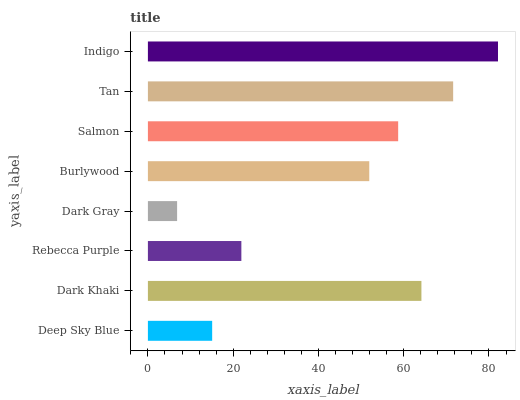Is Dark Gray the minimum?
Answer yes or no. Yes. Is Indigo the maximum?
Answer yes or no. Yes. Is Dark Khaki the minimum?
Answer yes or no. No. Is Dark Khaki the maximum?
Answer yes or no. No. Is Dark Khaki greater than Deep Sky Blue?
Answer yes or no. Yes. Is Deep Sky Blue less than Dark Khaki?
Answer yes or no. Yes. Is Deep Sky Blue greater than Dark Khaki?
Answer yes or no. No. Is Dark Khaki less than Deep Sky Blue?
Answer yes or no. No. Is Salmon the high median?
Answer yes or no. Yes. Is Burlywood the low median?
Answer yes or no. Yes. Is Indigo the high median?
Answer yes or no. No. Is Dark Khaki the low median?
Answer yes or no. No. 